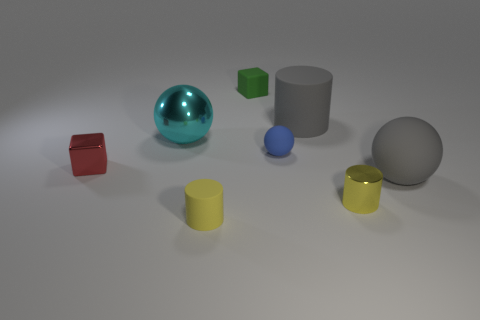Add 1 tiny yellow matte things. How many objects exist? 9 Subtract all blocks. How many objects are left? 6 Add 1 gray cylinders. How many gray cylinders exist? 2 Subtract 0 green spheres. How many objects are left? 8 Subtract all green shiny spheres. Subtract all red things. How many objects are left? 7 Add 1 small blue objects. How many small blue objects are left? 2 